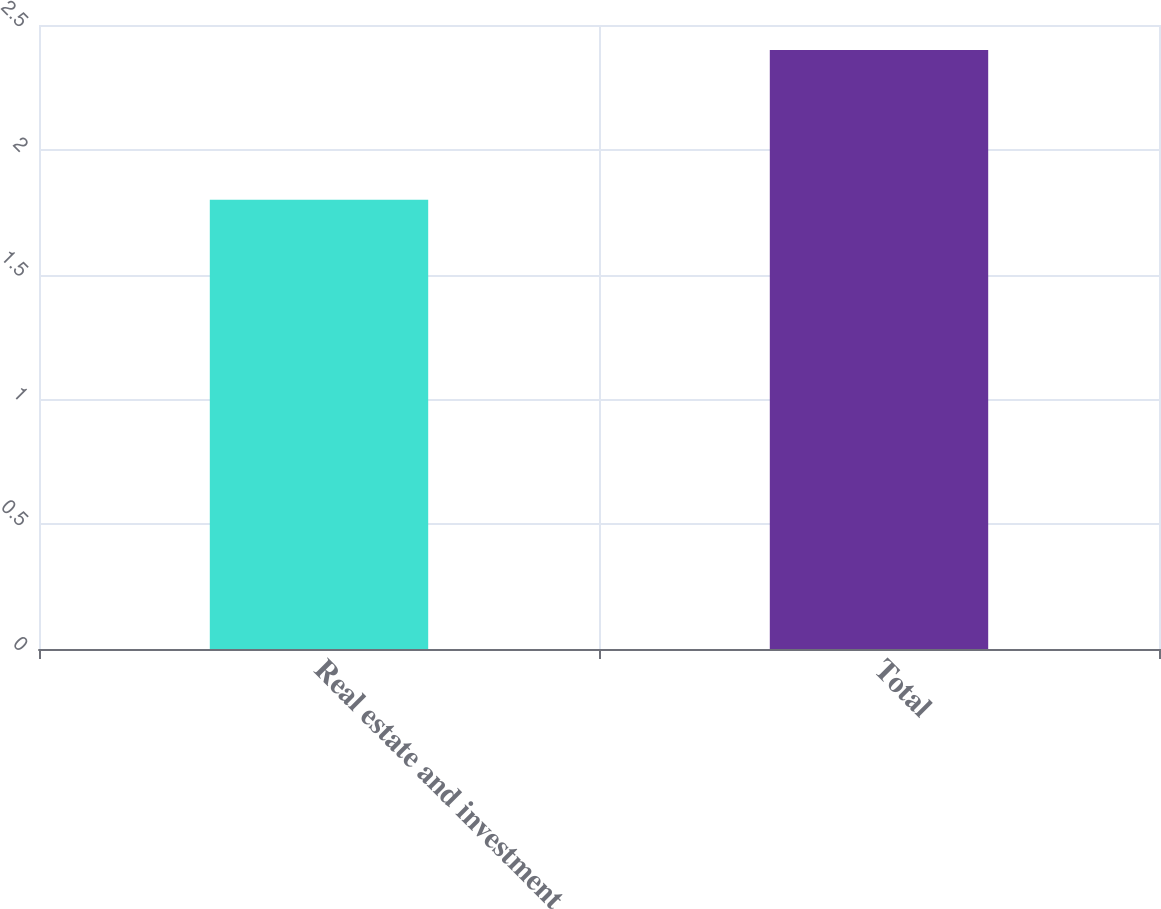Convert chart. <chart><loc_0><loc_0><loc_500><loc_500><bar_chart><fcel>Real estate and investment<fcel>Total<nl><fcel>1.8<fcel>2.4<nl></chart> 